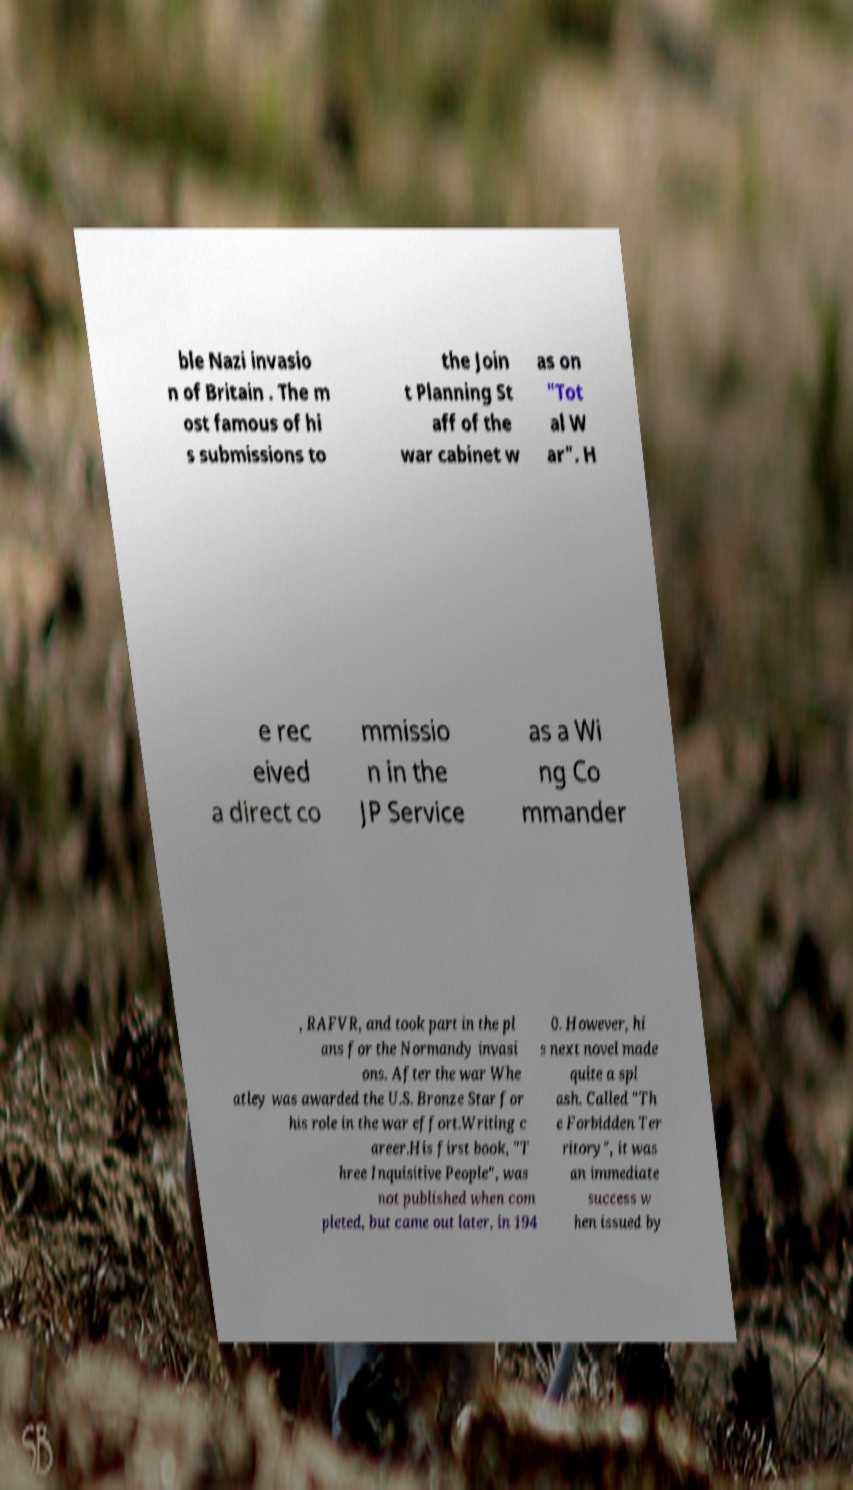What messages or text are displayed in this image? I need them in a readable, typed format. ble Nazi invasio n of Britain . The m ost famous of hi s submissions to the Join t Planning St aff of the war cabinet w as on "Tot al W ar". H e rec eived a direct co mmissio n in the JP Service as a Wi ng Co mmander , RAFVR, and took part in the pl ans for the Normandy invasi ons. After the war Whe atley was awarded the U.S. Bronze Star for his role in the war effort.Writing c areer.His first book, "T hree Inquisitive People", was not published when com pleted, but came out later, in 194 0. However, hi s next novel made quite a spl ash. Called "Th e Forbidden Ter ritory", it was an immediate success w hen issued by 